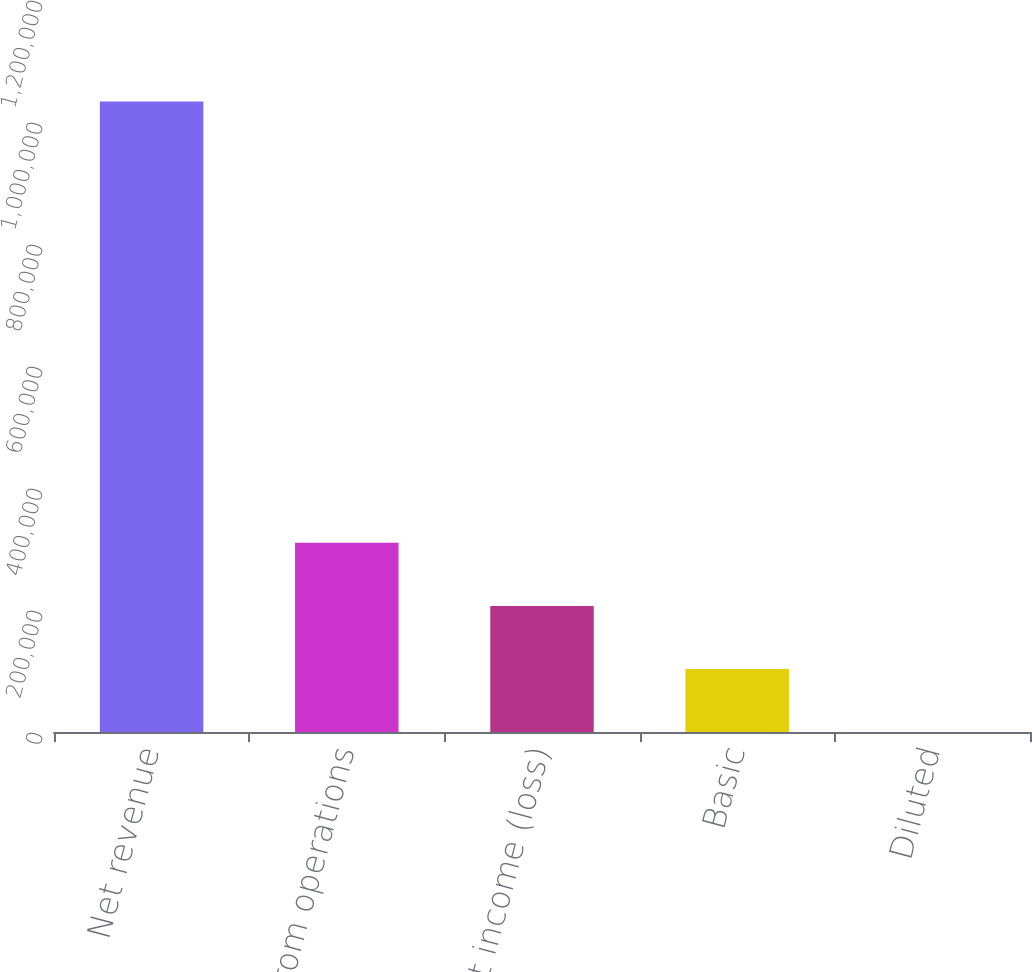Convert chart to OTSL. <chart><loc_0><loc_0><loc_500><loc_500><bar_chart><fcel>Net revenue<fcel>from operations<fcel>Net income (loss)<fcel>Basic<fcel>Diluted<nl><fcel>1.03369e+06<fcel>310109<fcel>206740<fcel>103371<fcel>1.37<nl></chart> 